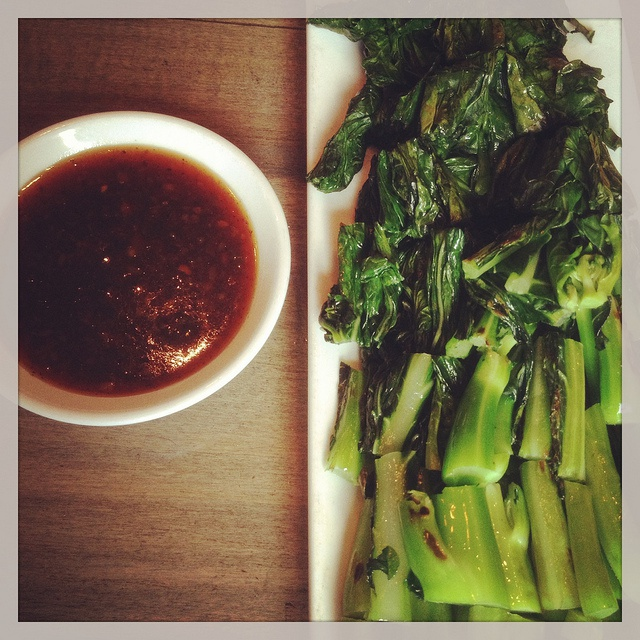Describe the objects in this image and their specific colors. I can see dining table in darkgray, maroon, gray, tan, and brown tones, bowl in darkgray, black, maroon, ivory, and brown tones, broccoli in darkgray, olive, and khaki tones, broccoli in darkgray, black, darkgreen, and olive tones, and broccoli in darkgray, olive, darkgreen, and black tones in this image. 